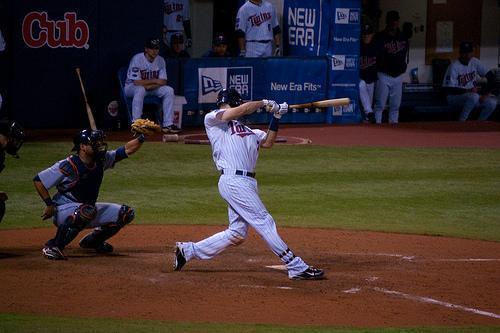How many bats in photo?
Give a very brief answer. 2. 